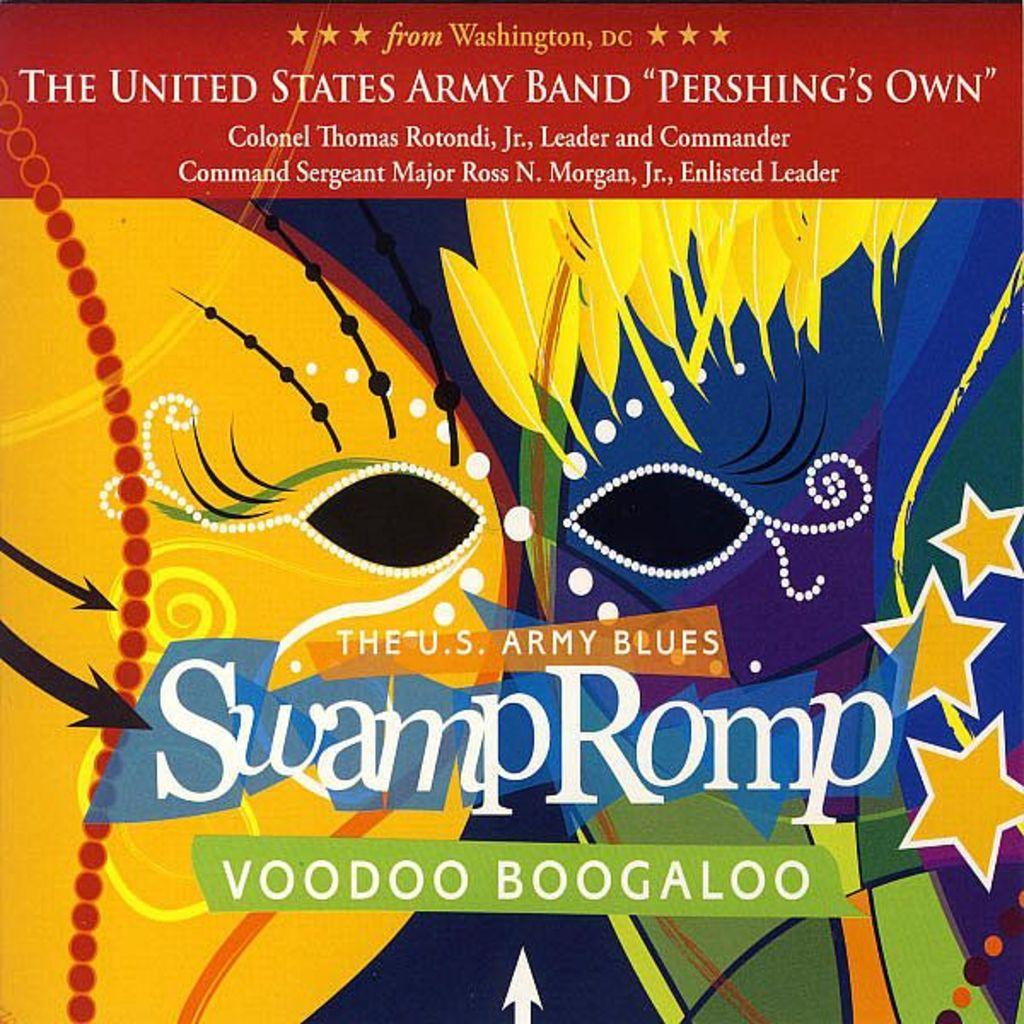<image>
Describe the image concisely. A poster for The U.S. Army Blues Swamp Romp. 